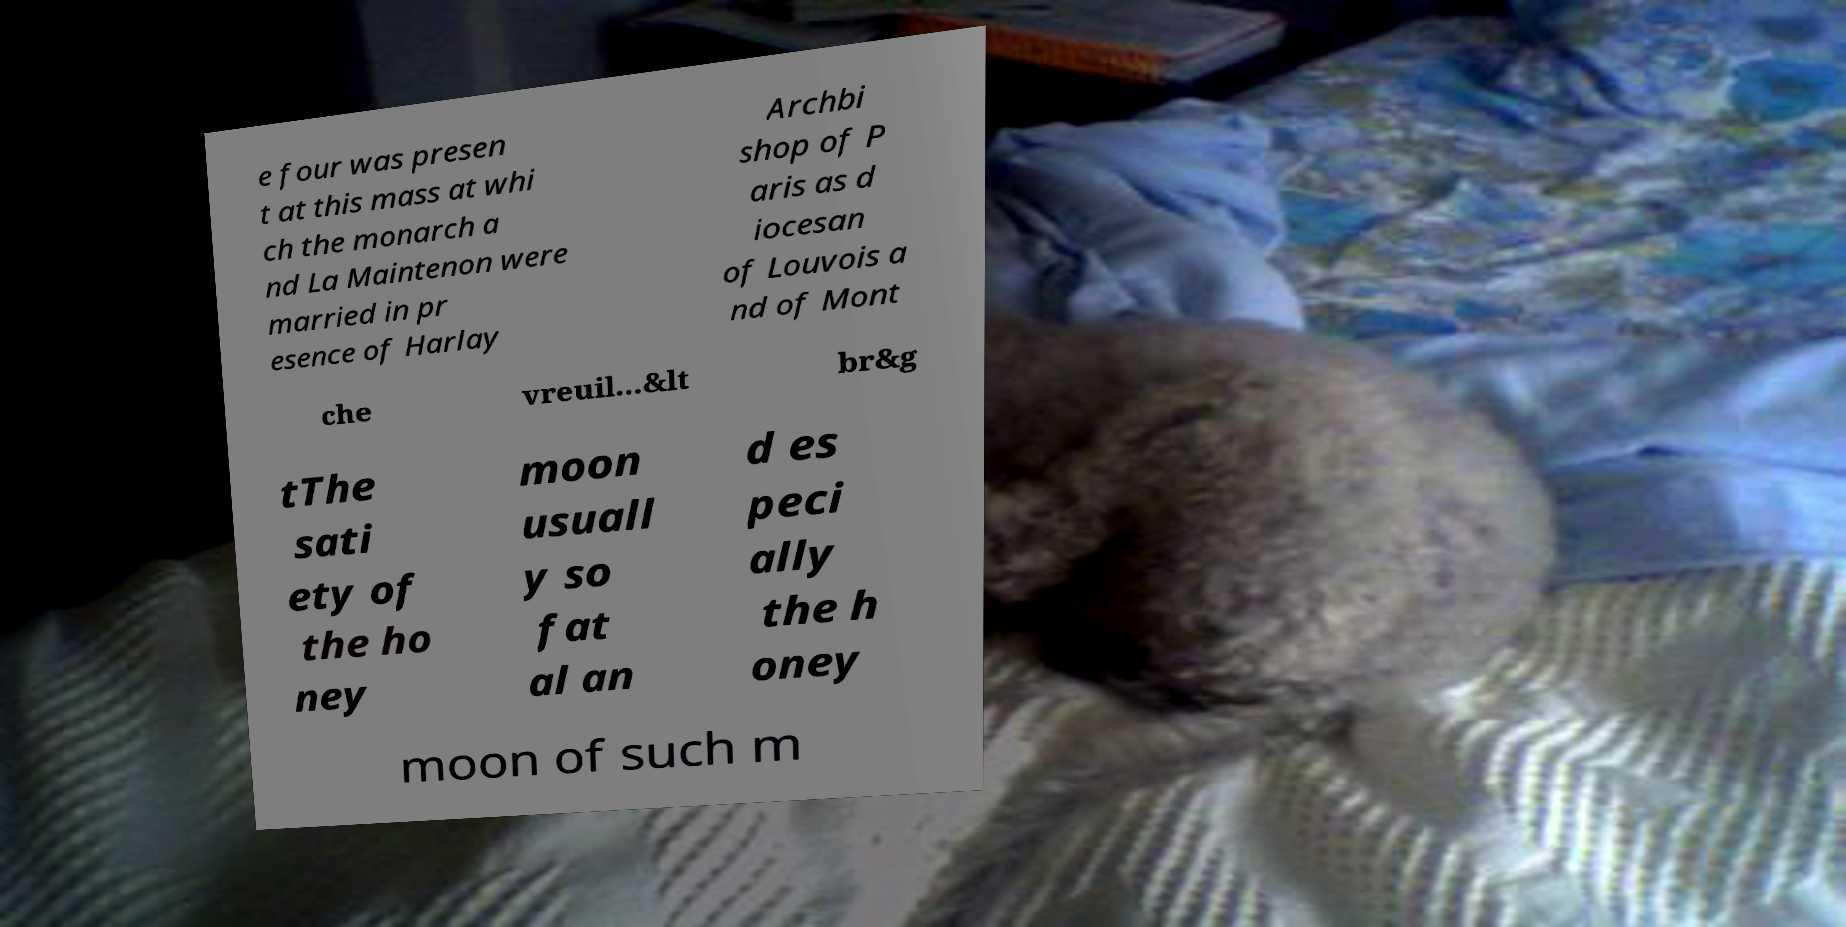For documentation purposes, I need the text within this image transcribed. Could you provide that? e four was presen t at this mass at whi ch the monarch a nd La Maintenon were married in pr esence of Harlay Archbi shop of P aris as d iocesan of Louvois a nd of Mont che vreuil...&lt br&g tThe sati ety of the ho ney moon usuall y so fat al an d es peci ally the h oney moon of such m 